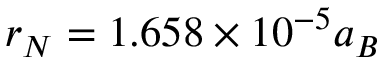Convert formula to latex. <formula><loc_0><loc_0><loc_500><loc_500>r _ { N } = 1 . 6 5 8 \times 1 0 ^ { - 5 } a _ { B }</formula> 